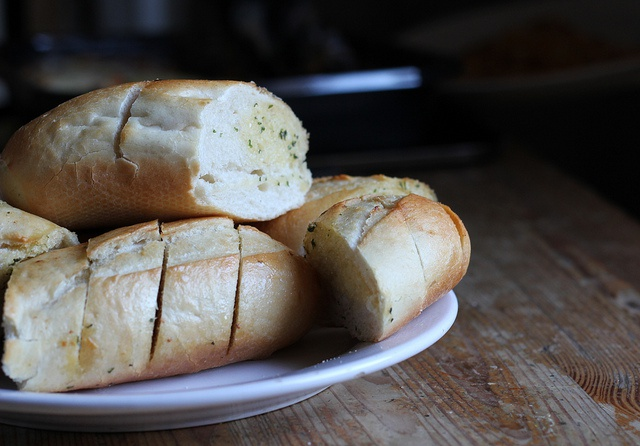Describe the objects in this image and their specific colors. I can see dining table in black, gray, darkgray, and lightgray tones, sandwich in black, darkgray, lightgray, tan, and gray tones, sandwich in black, lightgray, maroon, darkgray, and gray tones, and sandwich in black, lightgray, darkgray, and gray tones in this image. 